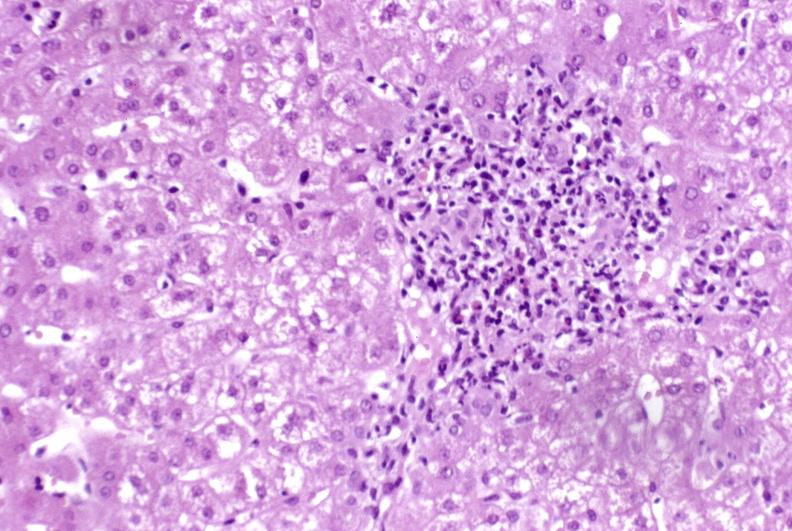does this image show moderate acute rejection?
Answer the question using a single word or phrase. Yes 